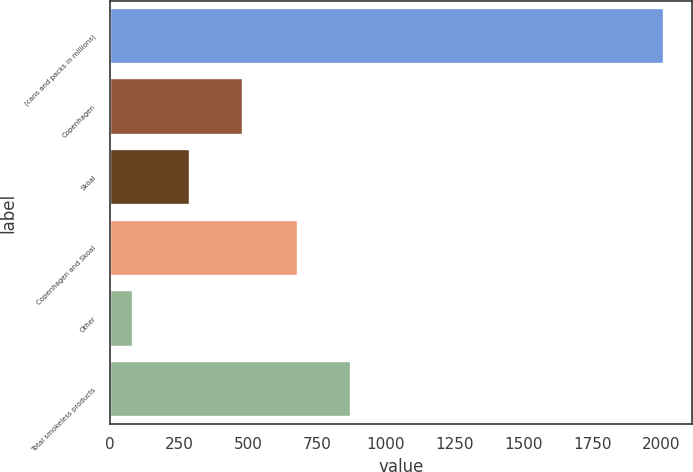<chart> <loc_0><loc_0><loc_500><loc_500><bar_chart><fcel>(cans and packs in millions)<fcel>Copenhagen<fcel>Skoal<fcel>Copenhagen and Skoal<fcel>Other<fcel>Total smokeless products<nl><fcel>2012<fcel>481.36<fcel>288.4<fcel>680.9<fcel>82.4<fcel>873.86<nl></chart> 